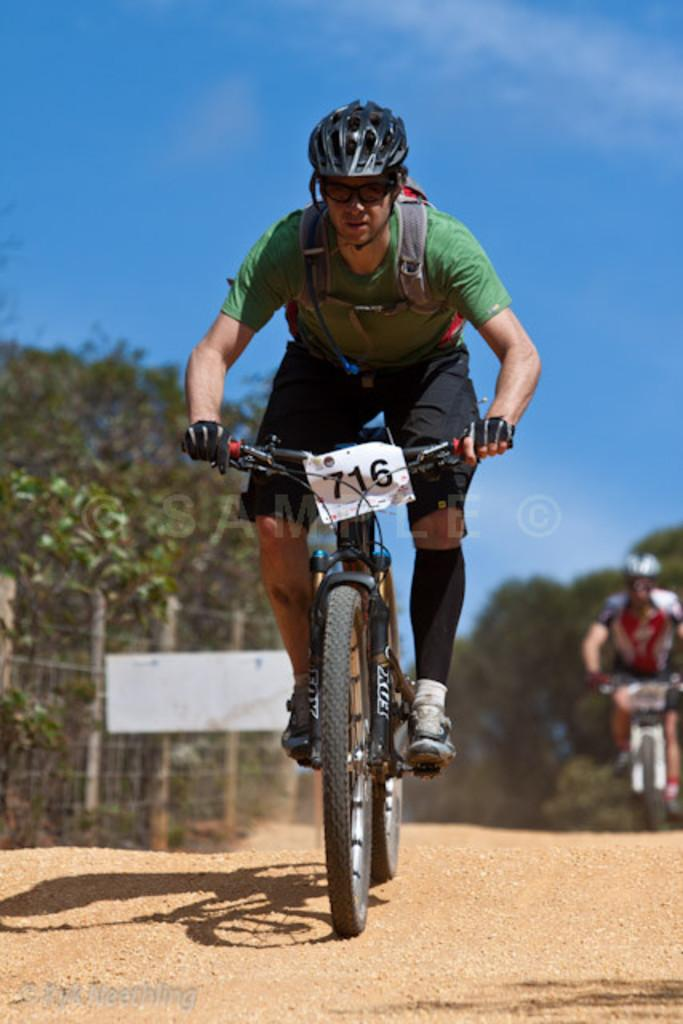What color is the sky in the image? The sky in the image is blue. What type of vegetation can be seen in the image? There are trees visible in the image. What activity are the two people engaged in? Two people are riding bicycles in the image. How many fingers can be seen holding the flame in the image? There are no fingers or flames present in the image. 